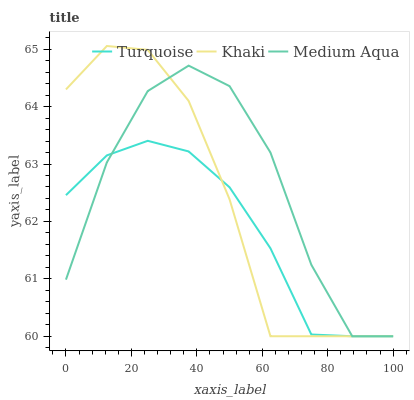Does Turquoise have the minimum area under the curve?
Answer yes or no. Yes. Does Medium Aqua have the maximum area under the curve?
Answer yes or no. Yes. Does Khaki have the minimum area under the curve?
Answer yes or no. No. Does Khaki have the maximum area under the curve?
Answer yes or no. No. Is Turquoise the smoothest?
Answer yes or no. Yes. Is Medium Aqua the roughest?
Answer yes or no. Yes. Is Khaki the smoothest?
Answer yes or no. No. Is Khaki the roughest?
Answer yes or no. No. Does Turquoise have the lowest value?
Answer yes or no. Yes. Does Khaki have the highest value?
Answer yes or no. Yes. Does Medium Aqua have the highest value?
Answer yes or no. No. Does Khaki intersect Turquoise?
Answer yes or no. Yes. Is Khaki less than Turquoise?
Answer yes or no. No. Is Khaki greater than Turquoise?
Answer yes or no. No. 